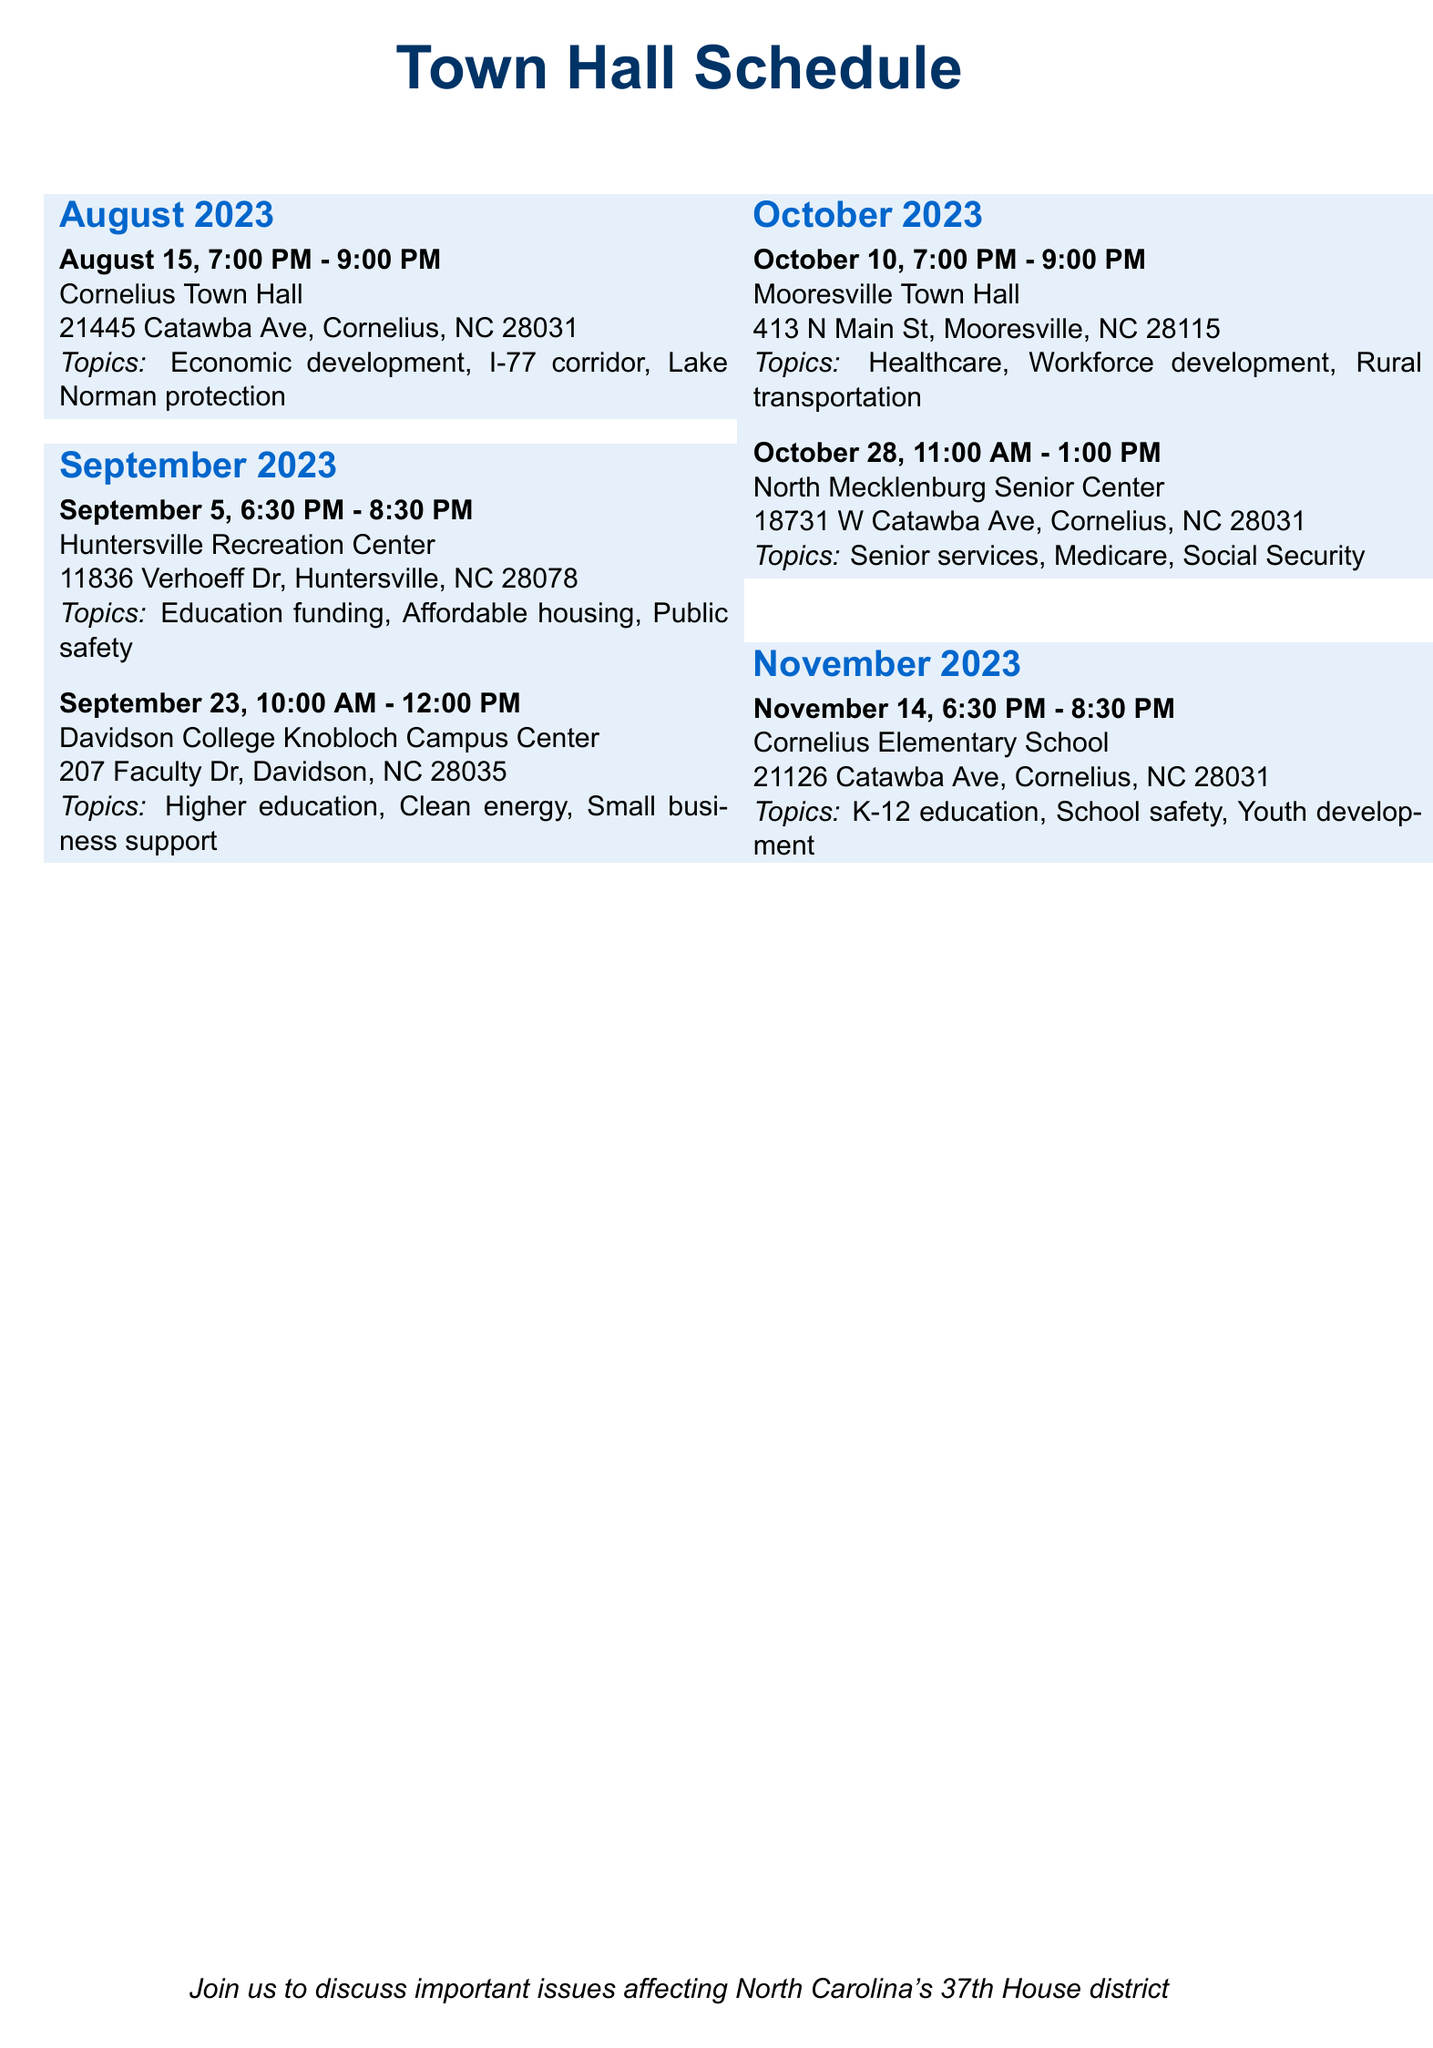What is the date of the first town hall meeting? The first town hall meeting is scheduled for August 15, 2023.
Answer: August 15, 2023 What is the location of the town hall on September 5, 2023? The location of the town hall on September 5, 2023, is Huntersville Recreation Center.
Answer: Huntersville Recreation Center How many topics will be discussed at the town hall in Mooresville on October 10, 2023? There are three topics listed for the town hall in Mooresville on October 10, 2023.
Answer: Three What time does the town hall at Davidson College start? The town hall at Davidson College starts at 10:00 AM.
Answer: 10:00 AM Which town hall focuses on senior services? The town hall on October 28, 2023, focuses on senior services.
Answer: October 28, 2023 How long is the town hall meeting at Cornelius Elementary School? The meeting at Cornelius Elementary School is scheduled for two hours, from 6:30 PM to 8:30 PM.
Answer: Two hours What are the discussion topics for the town hall on November 14, 2023? The discussion topics for that town hall are K-12 education funding, school safety, and youth development.
Answer: K-12 education funding, school safety, and youth development What is the address of the North Mecklenburg Senior Center? The address of the North Mecklenburg Senior Center is 18731 W Catawba Ave, Cornelius, NC 28031.
Answer: 18731 W Catawba Ave, Cornelius, NC 28031 What is the total number of meetings scheduled in October 2023? There are two meetings scheduled in October 2023.
Answer: Two 